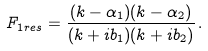<formula> <loc_0><loc_0><loc_500><loc_500>F _ { 1 r e s } = \frac { ( k - \alpha _ { 1 } ) ( k - \alpha _ { 2 } ) } { ( k + i b _ { 1 } ) ( k + i b _ { 2 } ) } \, .</formula> 